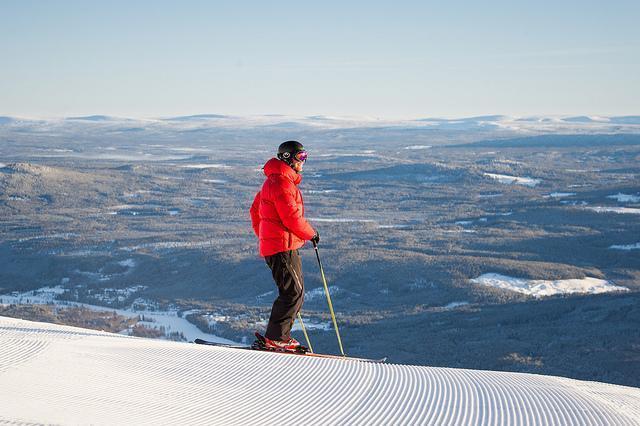How many bike on this image?
Give a very brief answer. 0. 